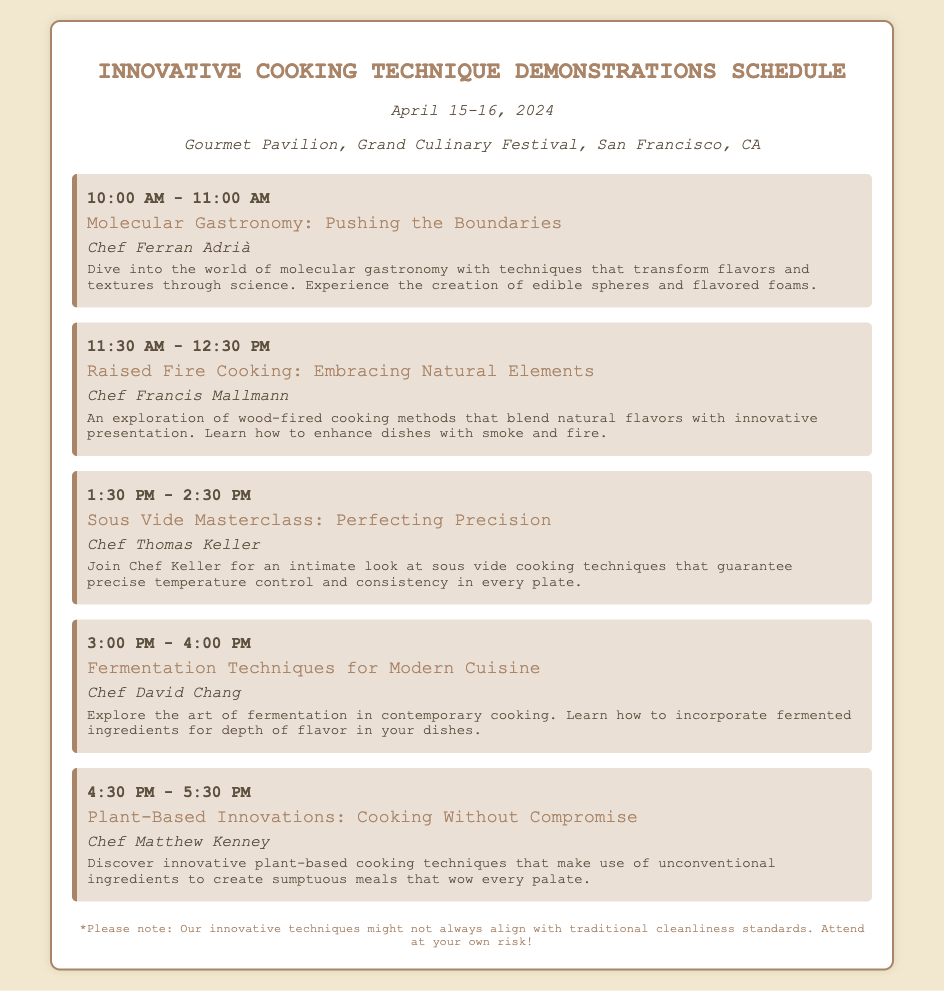What is the date of the culinary festival? The date of the culinary festival is mentioned at the beginning of the document as April 15-16, 2024.
Answer: April 15-16, 2024 Who is presenting the session on molecular gastronomy? The presenter of the session on molecular gastronomy is specified in the document as Chef Ferran Adrià.
Answer: Chef Ferran Adrià What time does the session on plant-based innovations start? The document states the start time for the session on plant-based innovations as 4:30 PM.
Answer: 4:30 PM How many cooking demonstration sessions are scheduled? The document lists a total of five cooking demonstration sessions in the schedule.
Answer: Five Which cooking technique involves fermentation? The document specifies that the fermentation technique is discussed in the session titled "Fermentation Techniques for Modern Cuisine."
Answer: Fermentation Techniques for Modern Cuisine What is the focus of the sous vide masterclass? The description of the sous vide masterclass indicates that it focuses on perfecting precision in cooking techniques.
Answer: Perfecting precision Who is the presenter for the raised fire cooking session? The document specifies the presenter for the raised fire cooking session as Chef Francis Mallmann.
Answer: Chef Francis Mallmann What type of disclaimer is included at the end of the document? The document includes a disclaimer about innovative techniques not always aligning with cleanliness standards, indicating a risk for attendees.
Answer: Cleanliness standards 